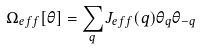Convert formula to latex. <formula><loc_0><loc_0><loc_500><loc_500>\Omega _ { e f f } [ \theta ] = \sum _ { q } J _ { e f f } ( { q } ) \theta _ { q } \theta _ { - { q } }</formula> 